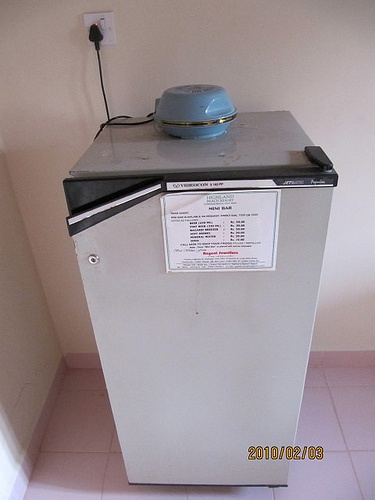Describe the objects in this image and their specific colors. I can see a refrigerator in gray, darkgray, lavender, and black tones in this image. 